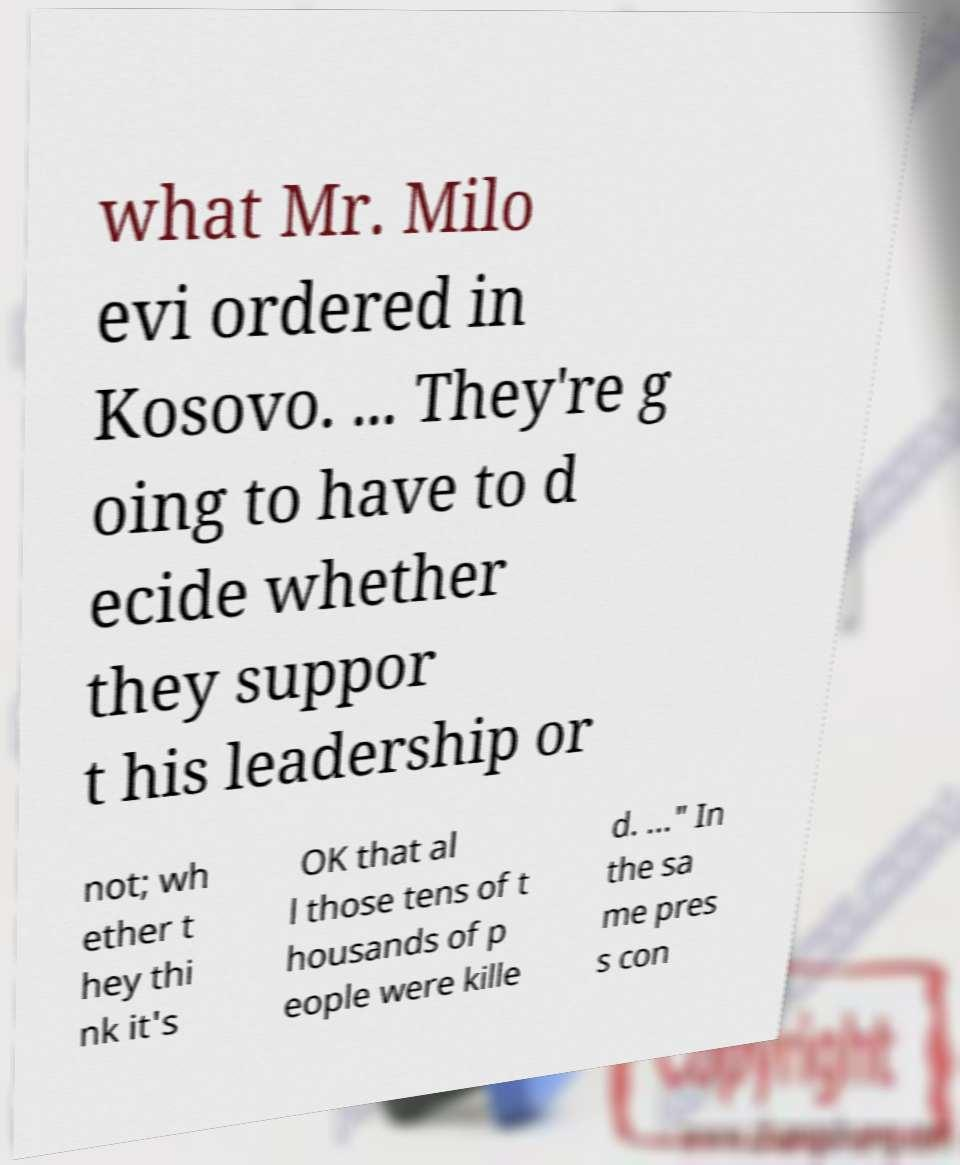Could you assist in decoding the text presented in this image and type it out clearly? what Mr. Milo evi ordered in Kosovo. ... They're g oing to have to d ecide whether they suppor t his leadership or not; wh ether t hey thi nk it's OK that al l those tens of t housands of p eople were kille d. ..." In the sa me pres s con 